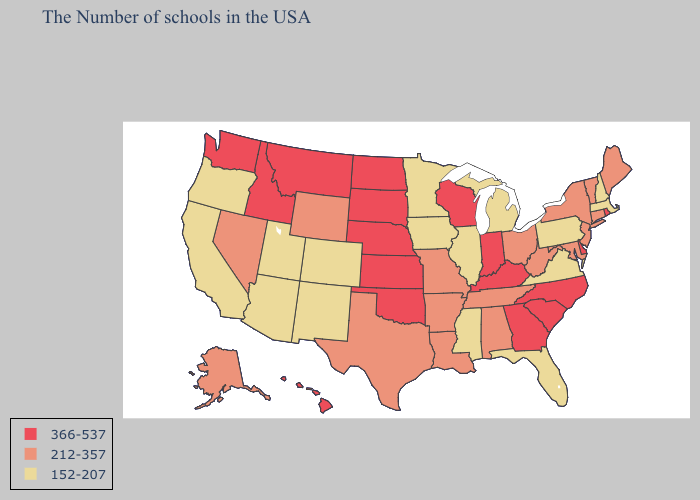Does the first symbol in the legend represent the smallest category?
Short answer required. No. Among the states that border Nebraska , does Missouri have the highest value?
Give a very brief answer. No. What is the highest value in the USA?
Keep it brief. 366-537. Does Kansas have the lowest value in the MidWest?
Concise answer only. No. What is the highest value in the Northeast ?
Concise answer only. 366-537. What is the highest value in the Northeast ?
Keep it brief. 366-537. What is the lowest value in the West?
Be succinct. 152-207. Name the states that have a value in the range 212-357?
Give a very brief answer. Maine, Vermont, Connecticut, New York, New Jersey, Maryland, West Virginia, Ohio, Alabama, Tennessee, Louisiana, Missouri, Arkansas, Texas, Wyoming, Nevada, Alaska. Name the states that have a value in the range 152-207?
Quick response, please. Massachusetts, New Hampshire, Pennsylvania, Virginia, Florida, Michigan, Illinois, Mississippi, Minnesota, Iowa, Colorado, New Mexico, Utah, Arizona, California, Oregon. What is the highest value in the USA?
Give a very brief answer. 366-537. How many symbols are there in the legend?
Give a very brief answer. 3. What is the highest value in the West ?
Concise answer only. 366-537. Does Arkansas have the same value as Iowa?
Concise answer only. No. What is the value of Tennessee?
Give a very brief answer. 212-357. What is the lowest value in the USA?
Be succinct. 152-207. 